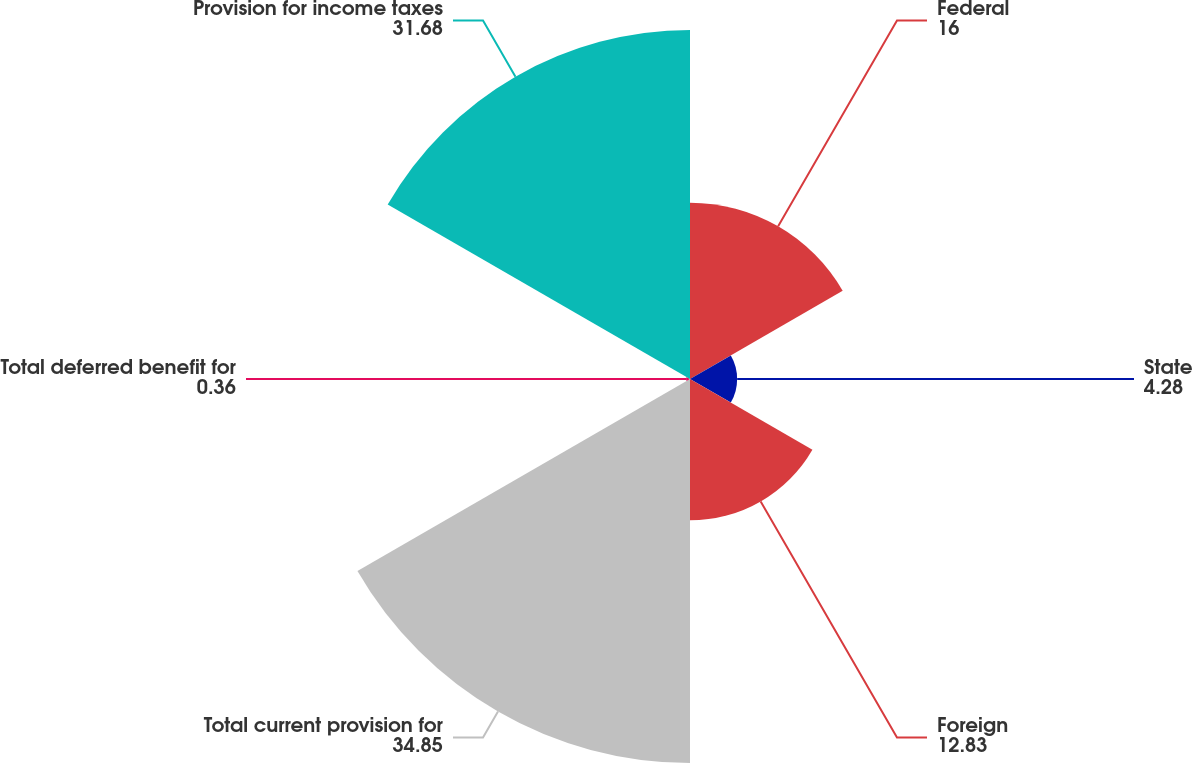<chart> <loc_0><loc_0><loc_500><loc_500><pie_chart><fcel>Federal<fcel>State<fcel>Foreign<fcel>Total current provision for<fcel>Total deferred benefit for<fcel>Provision for income taxes<nl><fcel>16.0%<fcel>4.28%<fcel>12.83%<fcel>34.85%<fcel>0.36%<fcel>31.68%<nl></chart> 